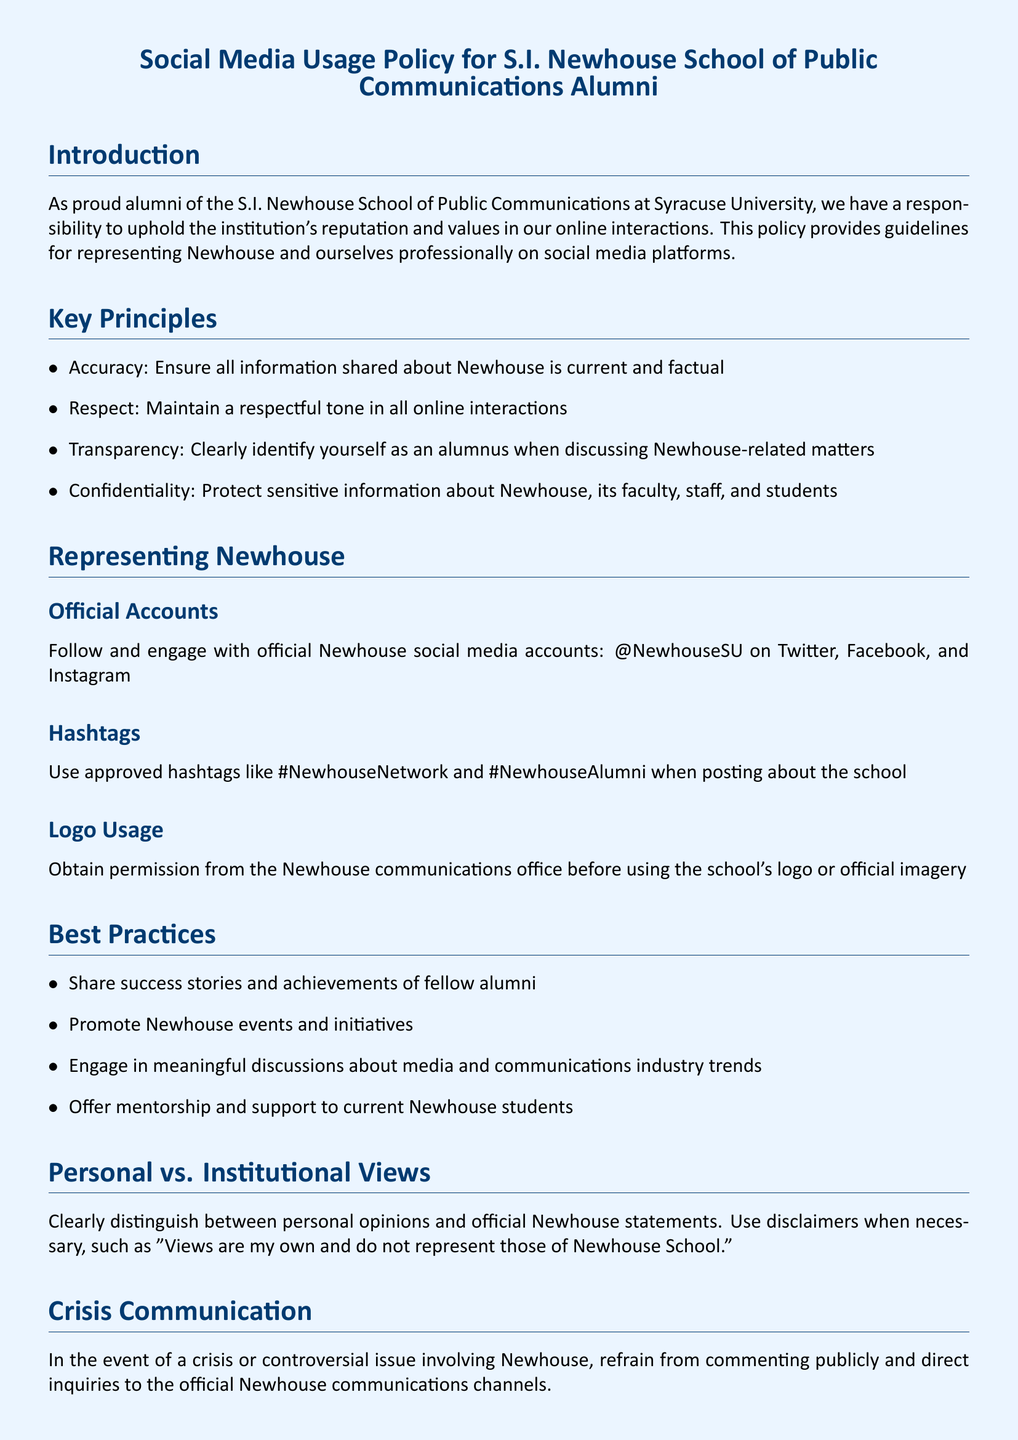What is the purpose of the policy? The policy outlines guidelines for alumni to represent Newhouse and themselves professionally on social media platforms.
Answer: Guidelines for alumni representation What social media accounts should alumni follow? Alumni should follow and engage with official Newhouse social media accounts, specified as @NewhouseSU.
Answer: @NewhouseSU What is one of the key principles mentioned in the document? One of the key principles listed in the document is "Accuracy," which emphasizes sharing current and factual information.
Answer: Accuracy What is required before using the Newhouse logo? Alumni must obtain permission from the Newhouse communications office before using the logo or official imagery.
Answer: Obtain permission What should alumni include when expressing personal views? They should include disclaimers stating that their views do not represent those of the Newhouse School.
Answer: Disclaimers What is the contact email for questions regarding the policy? The document provides the email newhousalumni@syr.edu for inquiries about the policy.
Answer: newhousalumni@syr.edu What should alumni do in a crisis situation involving Newhouse? They should refrain from commenting publicly and direct inquiries to official Newhouse communication channels.
Answer: Refrain from commenting What are approved hashtags for alumni to use? The document mentions two approved hashtags: #NewhouseNetwork and #NewhouseAlumni.
Answer: #NewhouseNetwork, #NewhouseAlumni How many key principles are outlined in the document? There are four key principles outlined in the section titled "Key Principles" in the document.
Answer: Four 